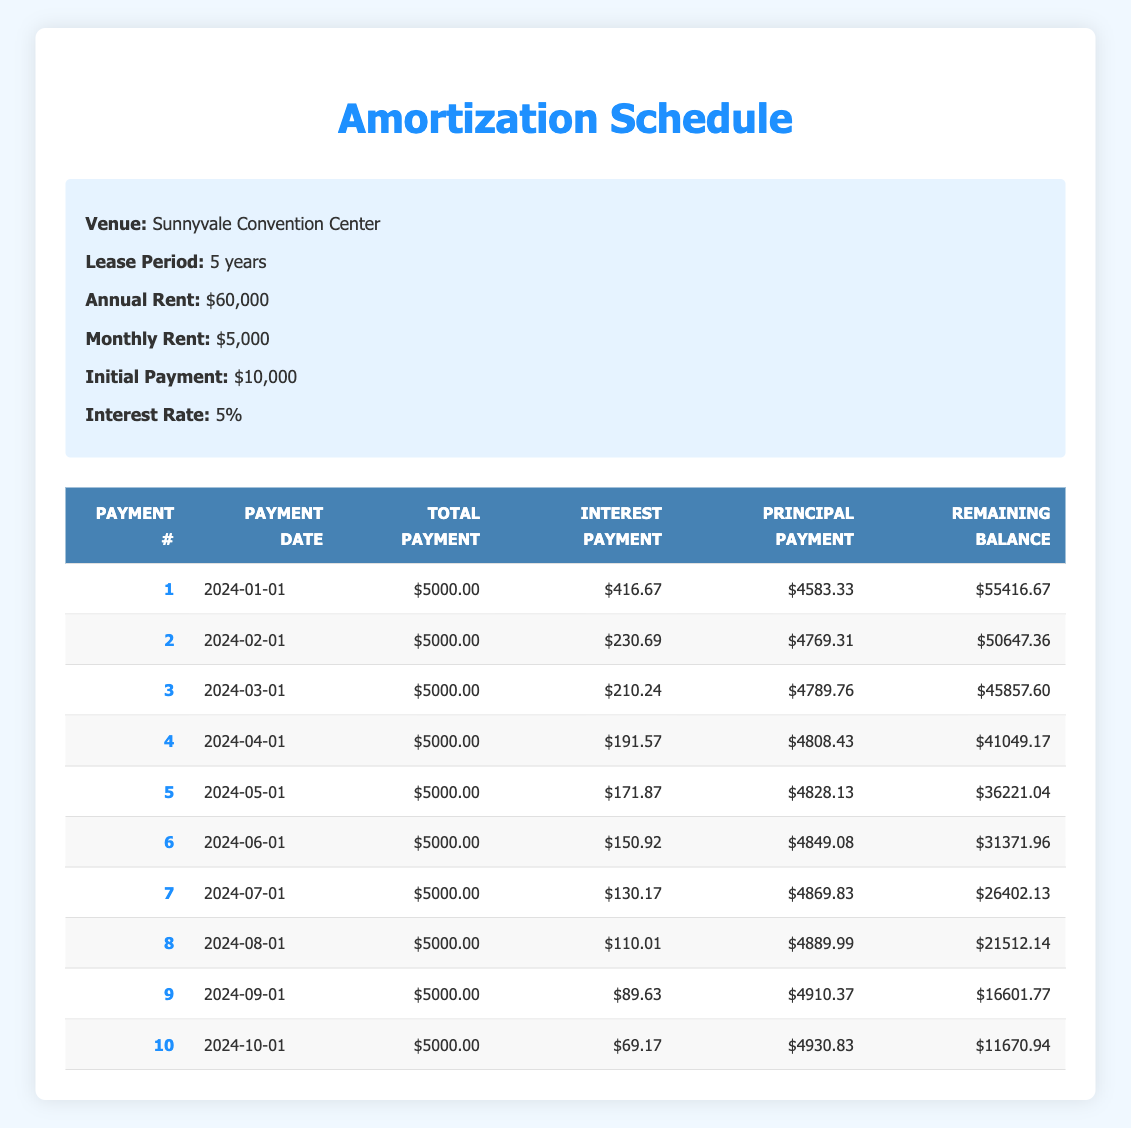What is the total payment for the first month? The first row in the table indicates that the total payment for the first month (payment number 1) is 5000.00.
Answer: 5000.00 What is the interest payment for the second month? The table shows that for payment number 2, the interest payment listed is 230.69.
Answer: 230.69 Is the principal payment for the third month greater than 4780? The principal payment for the third month (payment number 3) is 4789.76, which is greater than 4780.
Answer: Yes What is the remaining balance after the fifth payment? The table provides the remaining balance after the fifth payment (payment number 5) as 36221.04.
Answer: 36221.04 What is the total interest paid from the first to the fourth month? To find the total interest paid from the first to the fourth month, we sum the interest payments: 416.67 + 230.69 + 210.24 + 191.57 = 1049.17.
Answer: 1049.17 How much principal was paid off in the last payment? The last row indicates that the principal payment for the tenth month (payment number 10) is 4930.83.
Answer: 4930.83 What is the change in remaining balance from the third to the fourth payment? The remaining balance after the third payment is 45857.60, and after the fourth payment, it is 41049.17. The change is calculated as 45857.60 - 41049.17 = 4808.43.
Answer: 4808.43 What is the average interest payment from payment two to payment five? The interest payments from payment two to payment five are 230.69, 210.24, 191.57, and 171.87. Adding them gives 1004.37, and there are 4 payments, so the average is 1004.37/4 = 251.09.
Answer: 251.09 What is the total amount paid by the end of the tenth month? The total amount paid by the end of the tenth month includes 10 payments of 5000.00 each, yielding a total of 50000.00.
Answer: 50000.00 